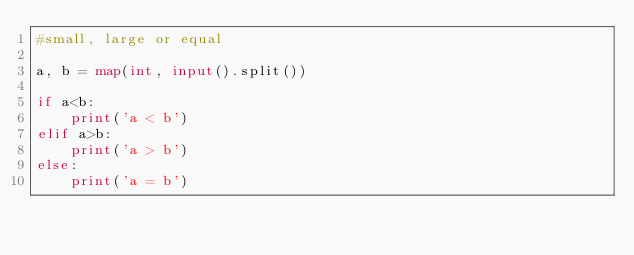<code> <loc_0><loc_0><loc_500><loc_500><_Python_>#small, large or equal

a, b = map(int, input().split())

if a<b:
	print('a < b')
elif a>b:
	print('a > b')
else:
	print('a = b')</code> 